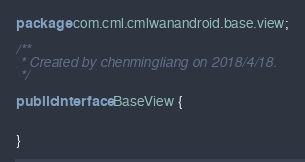Convert code to text. <code><loc_0><loc_0><loc_500><loc_500><_Java_>package com.cml.cmlwanandroid.base.view;

/**
 * Created by chenmingliang on 2018/4/18.
 */

public interface BaseView {


}
</code> 